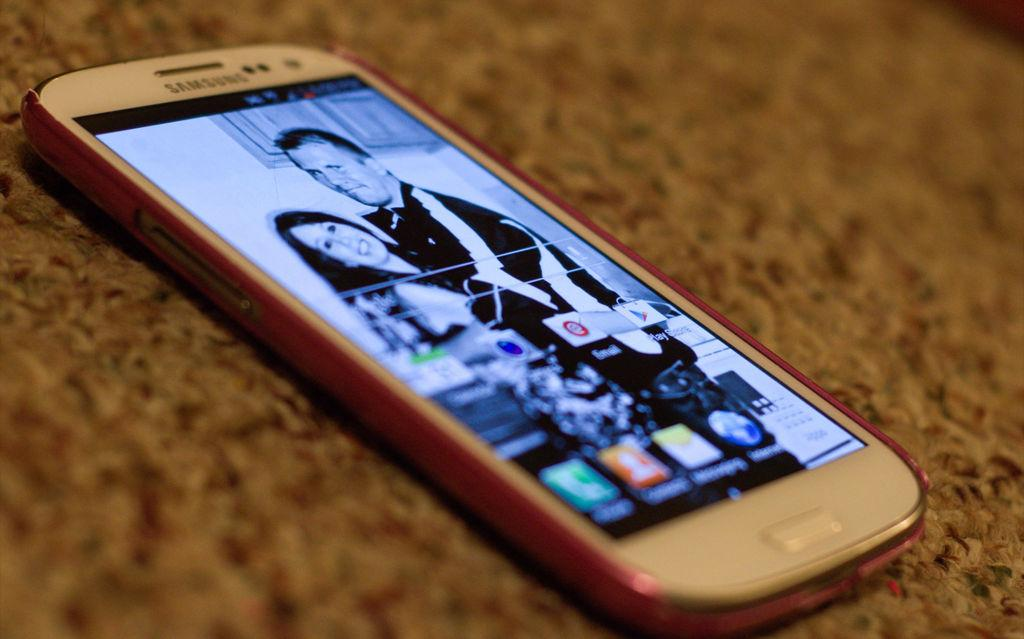<image>
Offer a succinct explanation of the picture presented. A Samsung phone displays a black and white picture. 